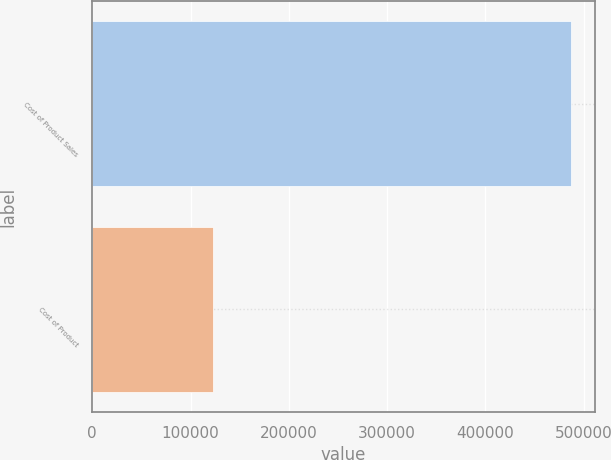Convert chart. <chart><loc_0><loc_0><loc_500><loc_500><bar_chart><fcel>Cost of Product Sales<fcel>Cost of Product<nl><fcel>487057<fcel>123350<nl></chart> 